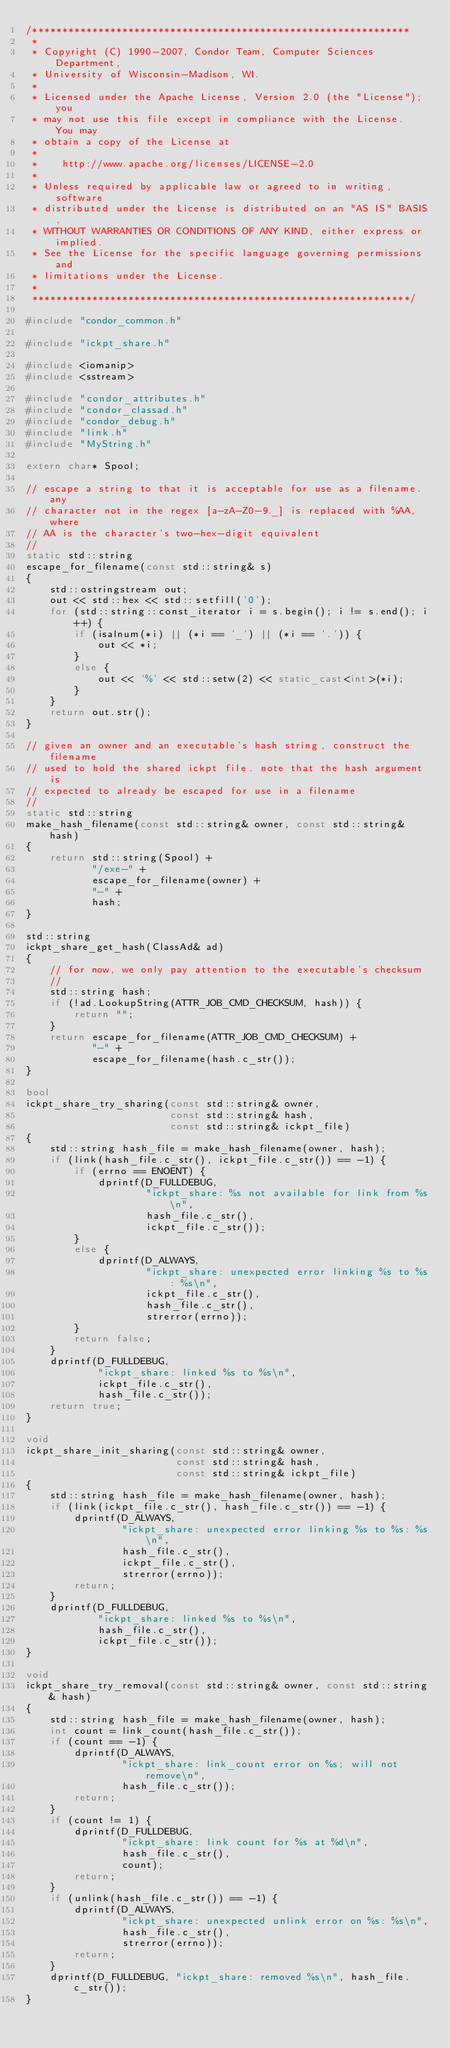Convert code to text. <code><loc_0><loc_0><loc_500><loc_500><_C++_>/***************************************************************
 *
 * Copyright (C) 1990-2007, Condor Team, Computer Sciences Department,
 * University of Wisconsin-Madison, WI.
 * 
 * Licensed under the Apache License, Version 2.0 (the "License"); you
 * may not use this file except in compliance with the License.  You may
 * obtain a copy of the License at
 * 
 *    http://www.apache.org/licenses/LICENSE-2.0
 * 
 * Unless required by applicable law or agreed to in writing, software
 * distributed under the License is distributed on an "AS IS" BASIS,
 * WITHOUT WARRANTIES OR CONDITIONS OF ANY KIND, either express or implied.
 * See the License for the specific language governing permissions and
 * limitations under the License.
 *
 ***************************************************************/

#include "condor_common.h"

#include "ickpt_share.h"

#include <iomanip>
#include <sstream>

#include "condor_attributes.h"
#include "condor_classad.h"
#include "condor_debug.h"
#include "link.h"
#include "MyString.h"

extern char* Spool;

// escape a string to that it is acceptable for use as a filename. any
// character not in the regex [a-zA-Z0-9._] is replaced with %AA, where
// AA is the character's two-hex-digit equivalent
//
static std::string
escape_for_filename(const std::string& s)
{
	std::ostringstream out;
	out << std::hex << std::setfill('0');
	for (std::string::const_iterator i = s.begin(); i != s.end(); i++) {
		if (isalnum(*i) || (*i == '_') || (*i == '.')) {
			out << *i;
		}
		else {
			out << '%' << std::setw(2) << static_cast<int>(*i);
		}
	}
	return out.str();
}

// given an owner and an executable's hash string, construct the filename
// used to hold the shared ickpt file. note that the hash argument is
// expected to already be escaped for use in a filename
//
static std::string
make_hash_filename(const std::string& owner, const std::string& hash)
{
	return std::string(Spool) +
	       "/exe-" +
	       escape_for_filename(owner) +
	       "-" +
	       hash;
}

std::string
ickpt_share_get_hash(ClassAd& ad)
{
	// for now, we only pay attention to the executable's checksum
	//
	std::string hash;
	if (!ad.LookupString(ATTR_JOB_CMD_CHECKSUM, hash)) {
		return "";
	}
	return escape_for_filename(ATTR_JOB_CMD_CHECKSUM) +
	       "-" +
	       escape_for_filename(hash.c_str());
}

bool
ickpt_share_try_sharing(const std::string& owner,
                        const std::string& hash,
                        const std::string& ickpt_file)
{
	std::string hash_file = make_hash_filename(owner, hash);
	if (link(hash_file.c_str(), ickpt_file.c_str()) == -1) {
		if (errno == ENOENT) {
			dprintf(D_FULLDEBUG,
			        "ickpt_share: %s not available for link from %s\n",
			        hash_file.c_str(),
			        ickpt_file.c_str());
		}
		else {
			dprintf(D_ALWAYS,
			        "ickpt_share: unexpected error linking %s to %s: %s\n",
			        ickpt_file.c_str(),
			        hash_file.c_str(),
			        strerror(errno));
		}
		return false;
	}
	dprintf(D_FULLDEBUG,
	        "ickpt_share: linked %s to %s\n",
	        ickpt_file.c_str(),
	        hash_file.c_str());
	return true;
}

void
ickpt_share_init_sharing(const std::string& owner,
                         const std::string& hash,
                         const std::string& ickpt_file)
{
	std::string hash_file = make_hash_filename(owner, hash);
	if (link(ickpt_file.c_str(), hash_file.c_str()) == -1) {
		dprintf(D_ALWAYS,
		        "ickpt_share: unexpected error linking %s to %s: %s\n",
		        hash_file.c_str(),
		        ickpt_file.c_str(),
		        strerror(errno));
		return;
	}
	dprintf(D_FULLDEBUG,
	        "ickpt_share: linked %s to %s\n",
	        hash_file.c_str(),
	        ickpt_file.c_str());
}

void
ickpt_share_try_removal(const std::string& owner, const std::string& hash)
{
	std::string hash_file = make_hash_filename(owner, hash);
	int count = link_count(hash_file.c_str());
	if (count == -1) {
		dprintf(D_ALWAYS,
		        "ickpt_share: link_count error on %s; will not remove\n",
		        hash_file.c_str());
		return;
	}
	if (count != 1) {
		dprintf(D_FULLDEBUG,
		        "ickpt_share: link count for %s at %d\n",
		        hash_file.c_str(),
		        count);
		return;
	}
	if (unlink(hash_file.c_str()) == -1) {
		dprintf(D_ALWAYS,
		        "ickpt_share: unexpected unlink error on %s: %s\n",
		        hash_file.c_str(),
		        strerror(errno));
		return;
	}
	dprintf(D_FULLDEBUG, "ickpt_share: removed %s\n", hash_file.c_str());
}
</code> 